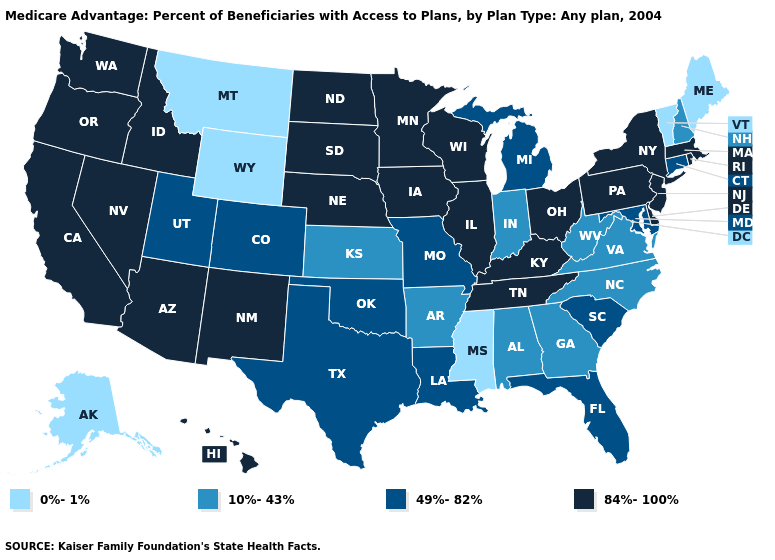Name the states that have a value in the range 0%-1%?
Answer briefly. Alaska, Maine, Mississippi, Montana, Vermont, Wyoming. Name the states that have a value in the range 49%-82%?
Short answer required. Colorado, Connecticut, Florida, Louisiana, Maryland, Michigan, Missouri, Oklahoma, South Carolina, Texas, Utah. What is the lowest value in the USA?
Quick response, please. 0%-1%. Name the states that have a value in the range 0%-1%?
Short answer required. Alaska, Maine, Mississippi, Montana, Vermont, Wyoming. Name the states that have a value in the range 49%-82%?
Short answer required. Colorado, Connecticut, Florida, Louisiana, Maryland, Michigan, Missouri, Oklahoma, South Carolina, Texas, Utah. Does Kansas have a lower value than New Mexico?
Give a very brief answer. Yes. Does the map have missing data?
Give a very brief answer. No. Does Mississippi have the lowest value in the South?
Short answer required. Yes. Does the map have missing data?
Keep it brief. No. Among the states that border New Hampshire , does Massachusetts have the lowest value?
Give a very brief answer. No. How many symbols are there in the legend?
Be succinct. 4. How many symbols are there in the legend?
Concise answer only. 4. Name the states that have a value in the range 49%-82%?
Write a very short answer. Colorado, Connecticut, Florida, Louisiana, Maryland, Michigan, Missouri, Oklahoma, South Carolina, Texas, Utah. Is the legend a continuous bar?
Give a very brief answer. No. Does Kansas have the highest value in the USA?
Be succinct. No. 